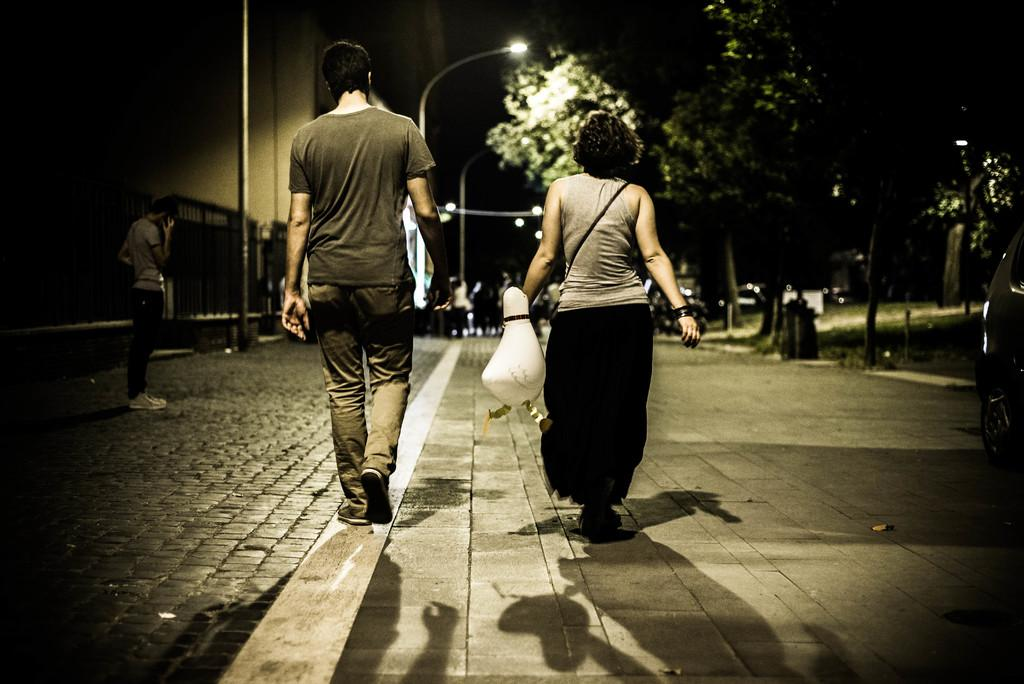What is happening on the road in the image? There is a group of people on the road in the image. What type of vegetation can be seen in the image? Trees and grass are visible in the image. What else is present on the road in the image? Vehicles are in the image. What can be seen in the background of the image? Street lights and buildings are visible in the background of the image. Can you describe the lighting conditions in the image? The image may have been taken during the night, as indicated by the presence of street lights. Can you see any examples of pins being used in the image? There are no pins present in the image. What type of feather can be seen on the road in the image? There are no feathers present in the image. 